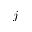Convert formula to latex. <formula><loc_0><loc_0><loc_500><loc_500>j</formula> 